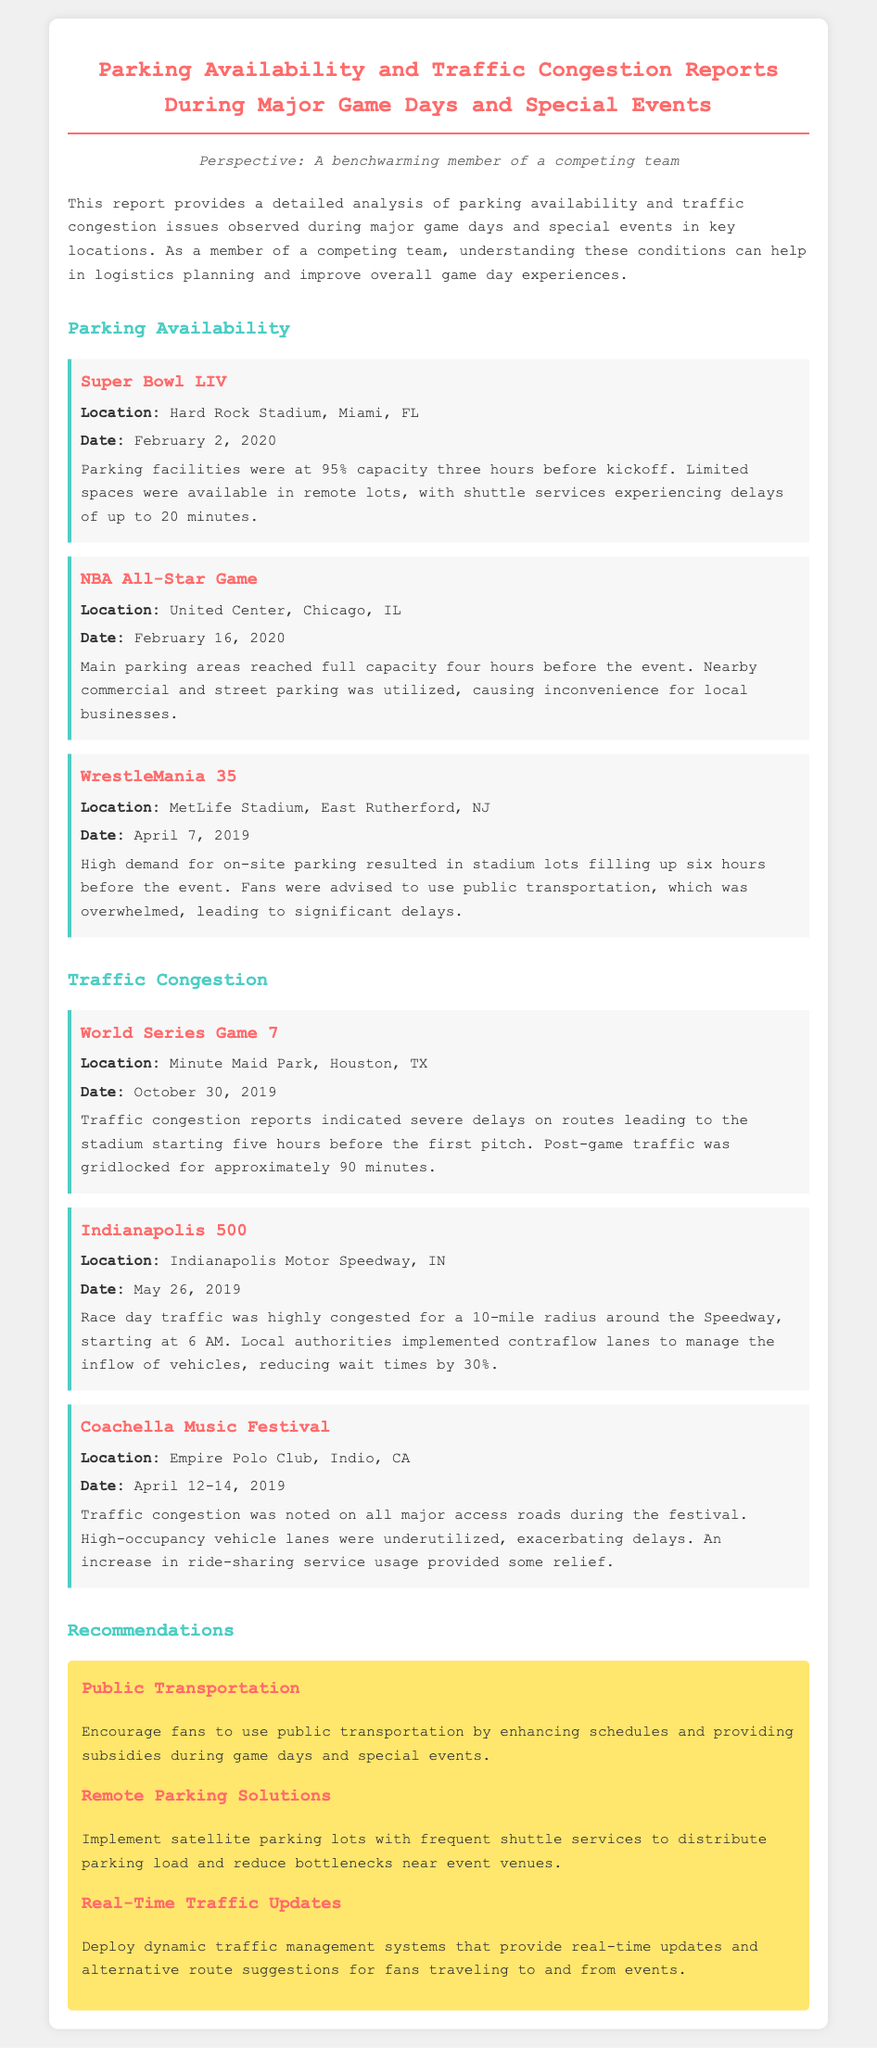What was the parking capacity at Hard Rock Stadium before Super Bowl LIV? The parking capacity reached 95% three hours before kickoff.
Answer: 95% How far in advance did the NBA All-Star Game parking areas reach full capacity? The main parking areas reached full capacity four hours before the event.
Answer: Four hours What transportation recommendation is suggested to reduce parking bottlenecks? The report suggests implementing satellite parking lots with frequent shuttle services.
Answer: Satellite parking lots What severe effect was noted during the World Series Game 7 regarding post-game traffic? Post-game traffic was gridlocked for approximately 90 minutes.
Answer: 90 minutes What was the significant timing for traffic congestion on race day at the Indianapolis 500? Traffic congestion started at 6 AM on race day.
Answer: 6 AM Which event reported high demand for on-site parking that filled up six hours in advance? WrestleMania 35 had high demand for on-site parking.
Answer: WrestleMania 35 What is one way recommended to encourage fans to use public transportation? Enhance schedules and provide subsidies during game days and special events.
Answer: Enhance schedules During which event was there an increase in ride-sharing service usage noted? Coachella Music Festival noted an increase in ride-sharing service usage.
Answer: Coachella Music Festival How many events are listed under the Traffic Congestion section of the report? There are three events listed under the Traffic Congestion section.
Answer: Three events 